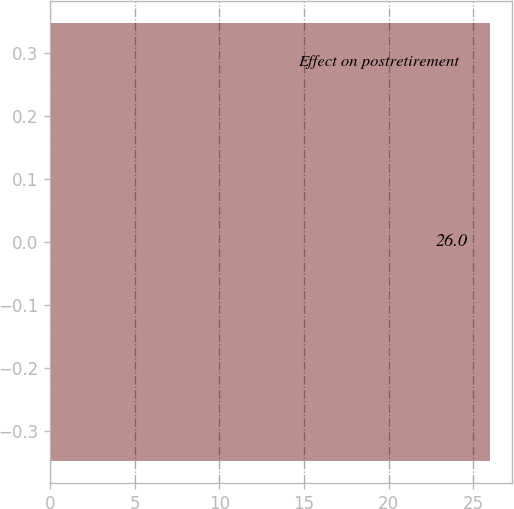Convert chart. <chart><loc_0><loc_0><loc_500><loc_500><bar_chart><fcel>Effect on postretirement<nl><fcel>26<nl></chart> 